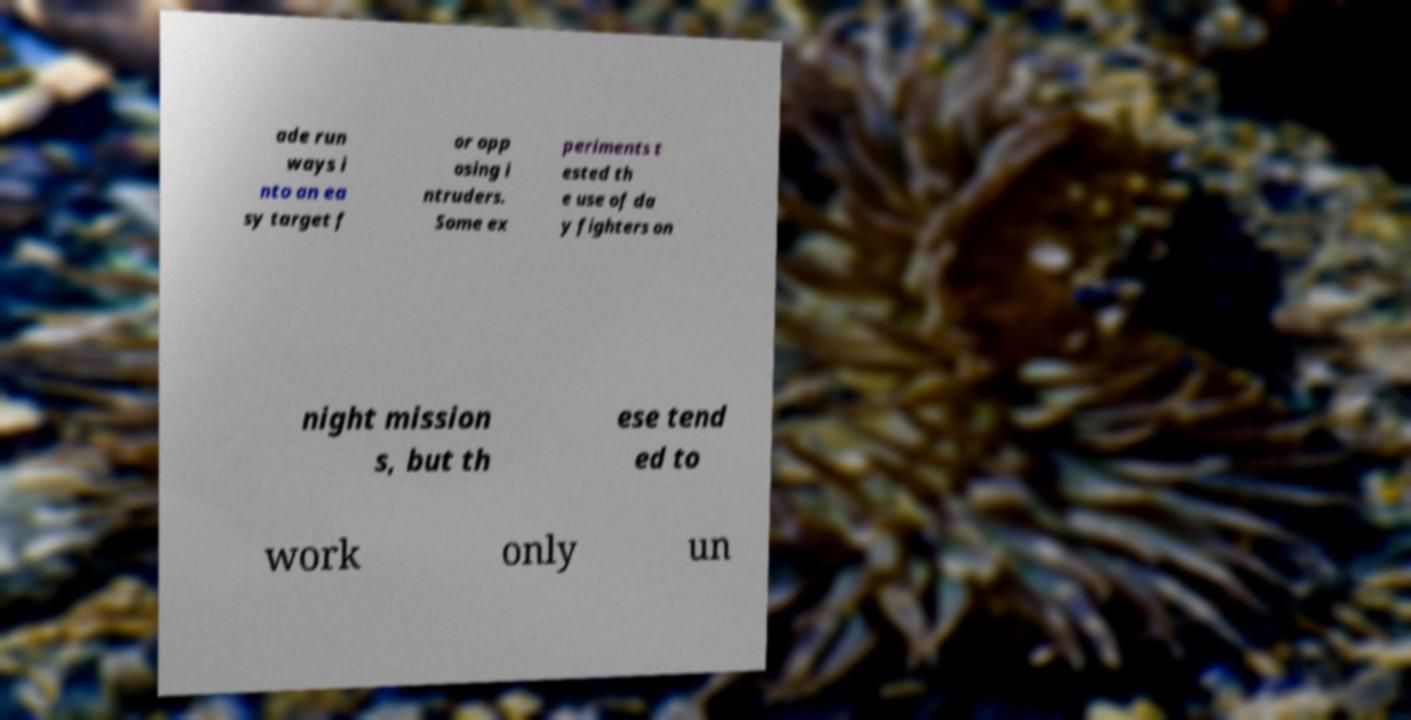Could you extract and type out the text from this image? ade run ways i nto an ea sy target f or opp osing i ntruders. Some ex periments t ested th e use of da y fighters on night mission s, but th ese tend ed to work only un 